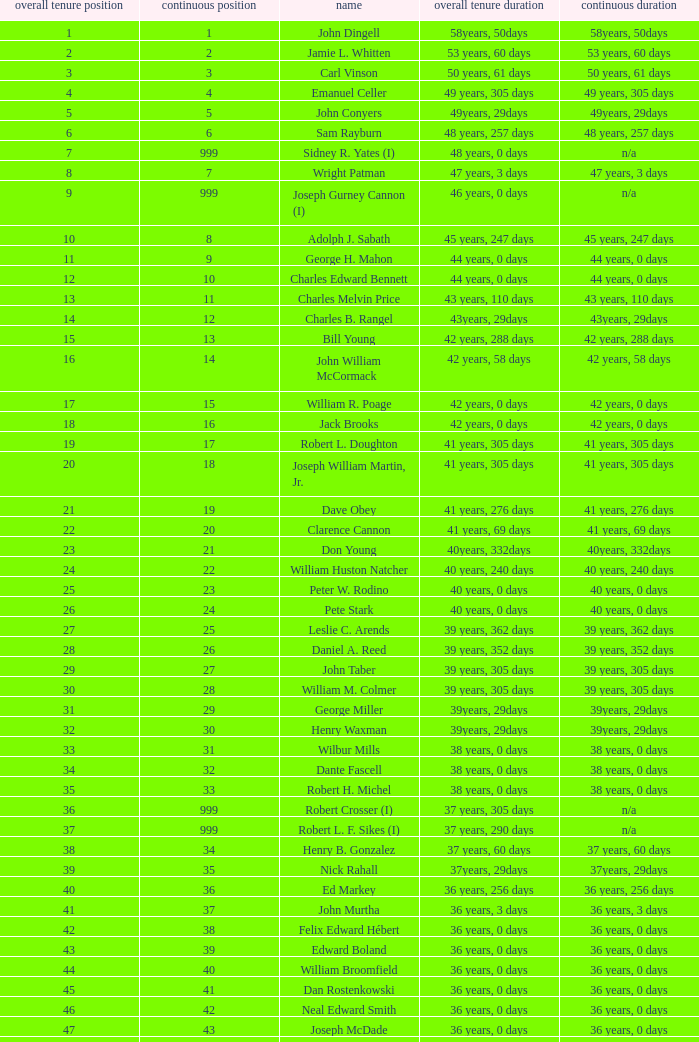Who has a total tenure time and uninterrupted time of 36 years, 0 days, as well as a total tenure rank of 49? James Oberstar. 